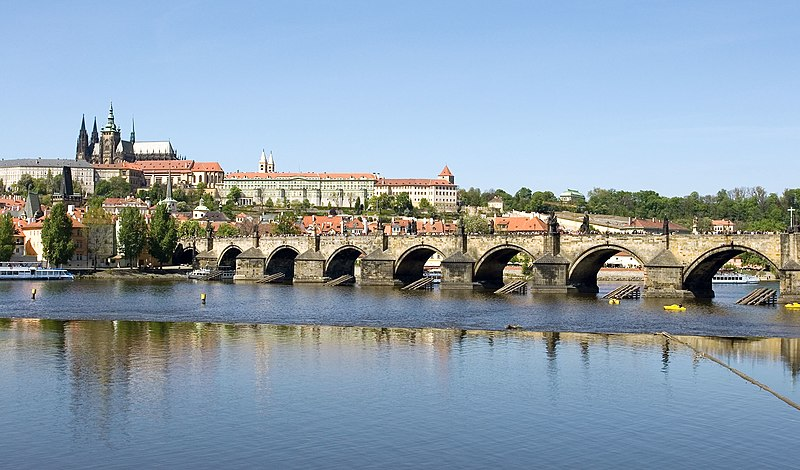I see there are buildings in the background. Can you discuss the architectural styles evident in this image? Certainly! The Prague skyline depicted in the background is a rich mosaic of architectural styles that span several eras. Prominent among them are Gothic structures like the Prague Castle and St. Vitus Cathedral, which tower over the city with their imposing spires. Additionally, you can observe examples of Baroque architecture, characterized by ornate details and dramatic forms. Renaissance influences are also visible, with some buildings displaying sgraffito decorations - a technique where layers of plaster are scratched to reveal a contrasting color beneath. Together, these styles reflect the city's diverse and evolving architectural heritage, each building telling its own story of the periods it has survived and the hands that have shaped it. 